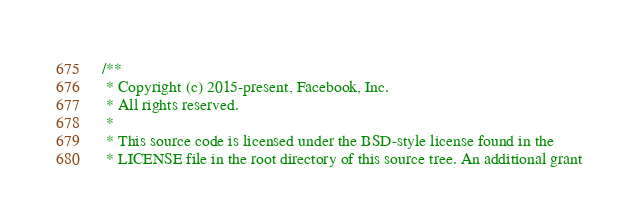<code> <loc_0><loc_0><loc_500><loc_500><_C_>/**
 * Copyright (c) 2015-present, Facebook, Inc.
 * All rights reserved.
 *
 * This source code is licensed under the BSD-style license found in the
 * LICENSE file in the root directory of this source tree. An additional grant</code> 